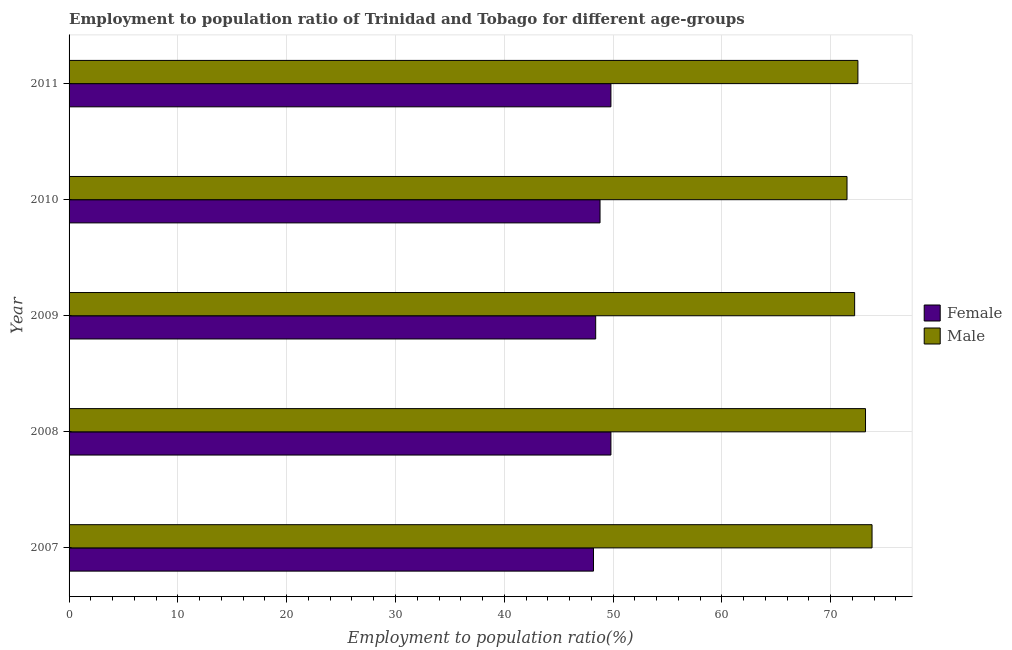Are the number of bars per tick equal to the number of legend labels?
Your answer should be compact. Yes. What is the employment to population ratio(male) in 2007?
Your response must be concise. 73.8. Across all years, what is the maximum employment to population ratio(female)?
Keep it short and to the point. 49.8. Across all years, what is the minimum employment to population ratio(female)?
Provide a succinct answer. 48.2. In which year was the employment to population ratio(male) minimum?
Offer a very short reply. 2010. What is the total employment to population ratio(female) in the graph?
Your answer should be very brief. 245. What is the difference between the employment to population ratio(male) in 2009 and the employment to population ratio(female) in 2007?
Offer a very short reply. 24. In the year 2010, what is the difference between the employment to population ratio(male) and employment to population ratio(female)?
Your answer should be compact. 22.7. In how many years, is the employment to population ratio(male) greater than 12 %?
Make the answer very short. 5. Is the employment to population ratio(female) in 2007 less than that in 2010?
Your answer should be compact. Yes. What is the difference between the highest and the second highest employment to population ratio(female)?
Your answer should be very brief. 0. In how many years, is the employment to population ratio(female) greater than the average employment to population ratio(female) taken over all years?
Keep it short and to the point. 2. Is the sum of the employment to population ratio(female) in 2008 and 2011 greater than the maximum employment to population ratio(male) across all years?
Make the answer very short. Yes. What does the 1st bar from the top in 2010 represents?
Provide a short and direct response. Male. What does the 2nd bar from the bottom in 2011 represents?
Offer a terse response. Male. Are all the bars in the graph horizontal?
Give a very brief answer. Yes. How many years are there in the graph?
Make the answer very short. 5. What is the difference between two consecutive major ticks on the X-axis?
Your answer should be very brief. 10. Does the graph contain grids?
Provide a short and direct response. Yes. Where does the legend appear in the graph?
Provide a short and direct response. Center right. How many legend labels are there?
Ensure brevity in your answer.  2. How are the legend labels stacked?
Your answer should be very brief. Vertical. What is the title of the graph?
Your response must be concise. Employment to population ratio of Trinidad and Tobago for different age-groups. Does "Official aid received" appear as one of the legend labels in the graph?
Your answer should be very brief. No. What is the label or title of the X-axis?
Your answer should be very brief. Employment to population ratio(%). What is the Employment to population ratio(%) of Female in 2007?
Offer a terse response. 48.2. What is the Employment to population ratio(%) in Male in 2007?
Offer a very short reply. 73.8. What is the Employment to population ratio(%) in Female in 2008?
Keep it short and to the point. 49.8. What is the Employment to population ratio(%) of Male in 2008?
Your response must be concise. 73.2. What is the Employment to population ratio(%) of Female in 2009?
Your answer should be compact. 48.4. What is the Employment to population ratio(%) of Male in 2009?
Your answer should be compact. 72.2. What is the Employment to population ratio(%) in Female in 2010?
Provide a short and direct response. 48.8. What is the Employment to population ratio(%) in Male in 2010?
Your answer should be very brief. 71.5. What is the Employment to population ratio(%) in Female in 2011?
Offer a terse response. 49.8. What is the Employment to population ratio(%) in Male in 2011?
Keep it short and to the point. 72.5. Across all years, what is the maximum Employment to population ratio(%) in Female?
Your answer should be very brief. 49.8. Across all years, what is the maximum Employment to population ratio(%) in Male?
Provide a succinct answer. 73.8. Across all years, what is the minimum Employment to population ratio(%) in Female?
Offer a terse response. 48.2. Across all years, what is the minimum Employment to population ratio(%) of Male?
Ensure brevity in your answer.  71.5. What is the total Employment to population ratio(%) of Female in the graph?
Your response must be concise. 245. What is the total Employment to population ratio(%) in Male in the graph?
Provide a succinct answer. 363.2. What is the difference between the Employment to population ratio(%) of Male in 2007 and that in 2008?
Provide a short and direct response. 0.6. What is the difference between the Employment to population ratio(%) of Female in 2007 and that in 2009?
Offer a terse response. -0.2. What is the difference between the Employment to population ratio(%) in Female in 2007 and that in 2010?
Make the answer very short. -0.6. What is the difference between the Employment to population ratio(%) of Male in 2007 and that in 2011?
Offer a very short reply. 1.3. What is the difference between the Employment to population ratio(%) in Female in 2008 and that in 2009?
Your answer should be very brief. 1.4. What is the difference between the Employment to population ratio(%) in Male in 2008 and that in 2009?
Your answer should be compact. 1. What is the difference between the Employment to population ratio(%) in Female in 2008 and that in 2010?
Give a very brief answer. 1. What is the difference between the Employment to population ratio(%) of Male in 2008 and that in 2010?
Ensure brevity in your answer.  1.7. What is the difference between the Employment to population ratio(%) in Male in 2008 and that in 2011?
Provide a succinct answer. 0.7. What is the difference between the Employment to population ratio(%) of Female in 2009 and that in 2010?
Your answer should be very brief. -0.4. What is the difference between the Employment to population ratio(%) of Male in 2009 and that in 2010?
Make the answer very short. 0.7. What is the difference between the Employment to population ratio(%) of Female in 2009 and that in 2011?
Offer a very short reply. -1.4. What is the difference between the Employment to population ratio(%) in Female in 2010 and that in 2011?
Ensure brevity in your answer.  -1. What is the difference between the Employment to population ratio(%) in Male in 2010 and that in 2011?
Provide a short and direct response. -1. What is the difference between the Employment to population ratio(%) in Female in 2007 and the Employment to population ratio(%) in Male in 2010?
Offer a terse response. -23.3. What is the difference between the Employment to population ratio(%) in Female in 2007 and the Employment to population ratio(%) in Male in 2011?
Your response must be concise. -24.3. What is the difference between the Employment to population ratio(%) of Female in 2008 and the Employment to population ratio(%) of Male in 2009?
Ensure brevity in your answer.  -22.4. What is the difference between the Employment to population ratio(%) of Female in 2008 and the Employment to population ratio(%) of Male in 2010?
Provide a succinct answer. -21.7. What is the difference between the Employment to population ratio(%) in Female in 2008 and the Employment to population ratio(%) in Male in 2011?
Your answer should be very brief. -22.7. What is the difference between the Employment to population ratio(%) of Female in 2009 and the Employment to population ratio(%) of Male in 2010?
Give a very brief answer. -23.1. What is the difference between the Employment to population ratio(%) of Female in 2009 and the Employment to population ratio(%) of Male in 2011?
Provide a short and direct response. -24.1. What is the difference between the Employment to population ratio(%) in Female in 2010 and the Employment to population ratio(%) in Male in 2011?
Offer a terse response. -23.7. What is the average Employment to population ratio(%) of Male per year?
Offer a very short reply. 72.64. In the year 2007, what is the difference between the Employment to population ratio(%) in Female and Employment to population ratio(%) in Male?
Offer a very short reply. -25.6. In the year 2008, what is the difference between the Employment to population ratio(%) in Female and Employment to population ratio(%) in Male?
Ensure brevity in your answer.  -23.4. In the year 2009, what is the difference between the Employment to population ratio(%) of Female and Employment to population ratio(%) of Male?
Provide a succinct answer. -23.8. In the year 2010, what is the difference between the Employment to population ratio(%) of Female and Employment to population ratio(%) of Male?
Ensure brevity in your answer.  -22.7. In the year 2011, what is the difference between the Employment to population ratio(%) of Female and Employment to population ratio(%) of Male?
Provide a short and direct response. -22.7. What is the ratio of the Employment to population ratio(%) in Female in 2007 to that in 2008?
Provide a short and direct response. 0.97. What is the ratio of the Employment to population ratio(%) in Male in 2007 to that in 2008?
Your answer should be very brief. 1.01. What is the ratio of the Employment to population ratio(%) of Female in 2007 to that in 2009?
Make the answer very short. 1. What is the ratio of the Employment to population ratio(%) in Male in 2007 to that in 2009?
Offer a very short reply. 1.02. What is the ratio of the Employment to population ratio(%) of Male in 2007 to that in 2010?
Your answer should be compact. 1.03. What is the ratio of the Employment to population ratio(%) in Female in 2007 to that in 2011?
Your answer should be very brief. 0.97. What is the ratio of the Employment to population ratio(%) in Male in 2007 to that in 2011?
Provide a short and direct response. 1.02. What is the ratio of the Employment to population ratio(%) in Female in 2008 to that in 2009?
Ensure brevity in your answer.  1.03. What is the ratio of the Employment to population ratio(%) of Male in 2008 to that in 2009?
Offer a terse response. 1.01. What is the ratio of the Employment to population ratio(%) in Female in 2008 to that in 2010?
Give a very brief answer. 1.02. What is the ratio of the Employment to population ratio(%) of Male in 2008 to that in 2010?
Offer a terse response. 1.02. What is the ratio of the Employment to population ratio(%) of Female in 2008 to that in 2011?
Your response must be concise. 1. What is the ratio of the Employment to population ratio(%) of Male in 2008 to that in 2011?
Your response must be concise. 1.01. What is the ratio of the Employment to population ratio(%) in Female in 2009 to that in 2010?
Give a very brief answer. 0.99. What is the ratio of the Employment to population ratio(%) in Male in 2009 to that in 2010?
Provide a short and direct response. 1.01. What is the ratio of the Employment to population ratio(%) of Female in 2009 to that in 2011?
Provide a short and direct response. 0.97. What is the ratio of the Employment to population ratio(%) of Female in 2010 to that in 2011?
Keep it short and to the point. 0.98. What is the ratio of the Employment to population ratio(%) of Male in 2010 to that in 2011?
Keep it short and to the point. 0.99. What is the difference between the highest and the second highest Employment to population ratio(%) in Male?
Offer a terse response. 0.6. 